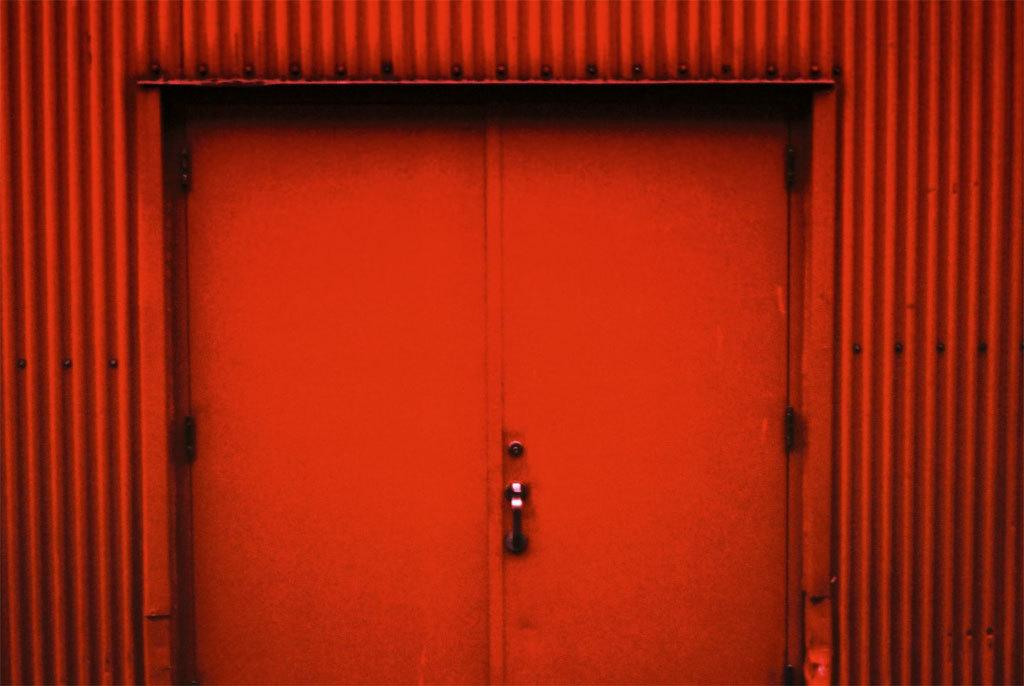What type of structure can be seen in the image? There is a wall in the image. Is there any entrance visible in the image? Yes, there is a door in the image. What color are the wall and door in the image? The wall and door are red in color. Can you see any cans of paint on the wall in the image? There is no mention of cans of paint in the image, so we cannot determine if they are present or not. 